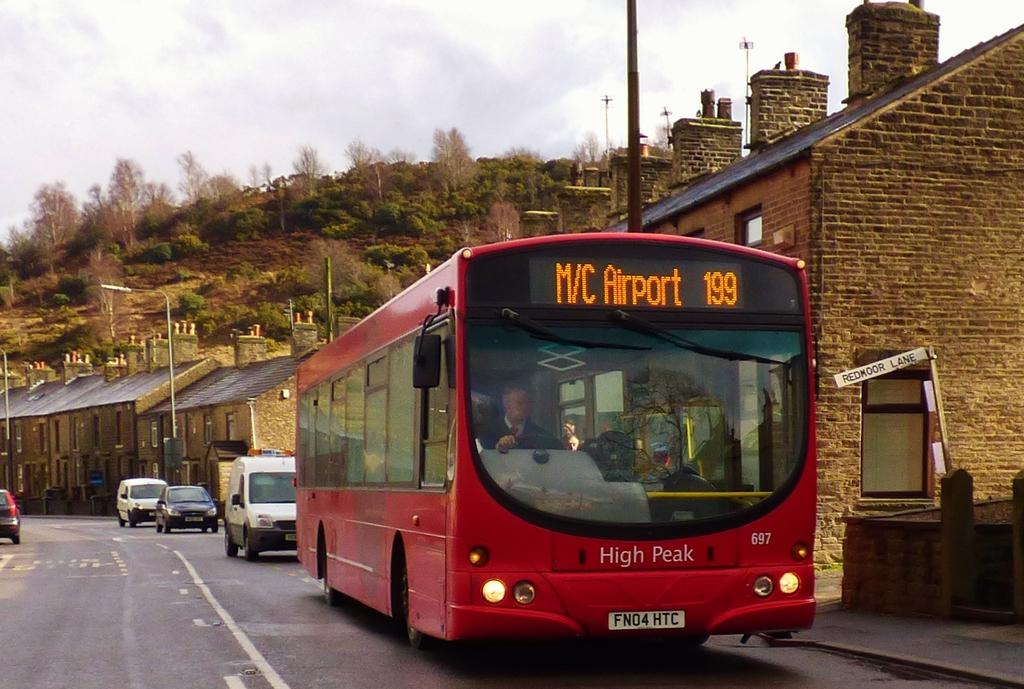What is happening in the image? There are vehicles on a road in the image. What can be seen in the background of the image? There are houses, light poles, trees, a mountain, and the sky visible in the background of the image. How many different types of structures are present in the background? There are at least four different types of structures present in the background: houses, light poles, trees, and a mountain. Is there a judge holding an umbrella in the image? There is no judge or umbrella present in the image. What type of rest can be seen in the image? There is no rest or resting area visible in the image; it primarily features vehicles on a road and structures in the background. 